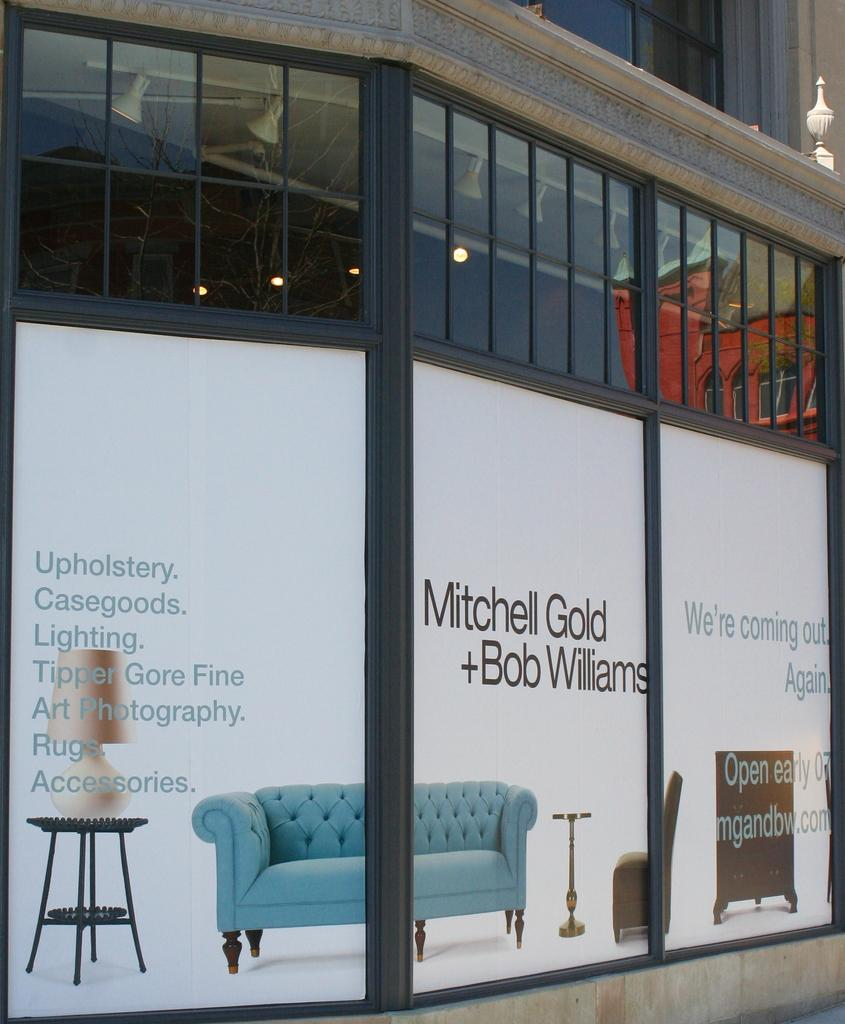What type of door is visible in the image? There is a glass door in the image. What is on the glass door? There are posters on the glass door. What type of furniture is visible in the image? There is no furniture visible in the image; it only features a glass door with posters on it. Can you see any toads in the image? There are no toads present in the image. 